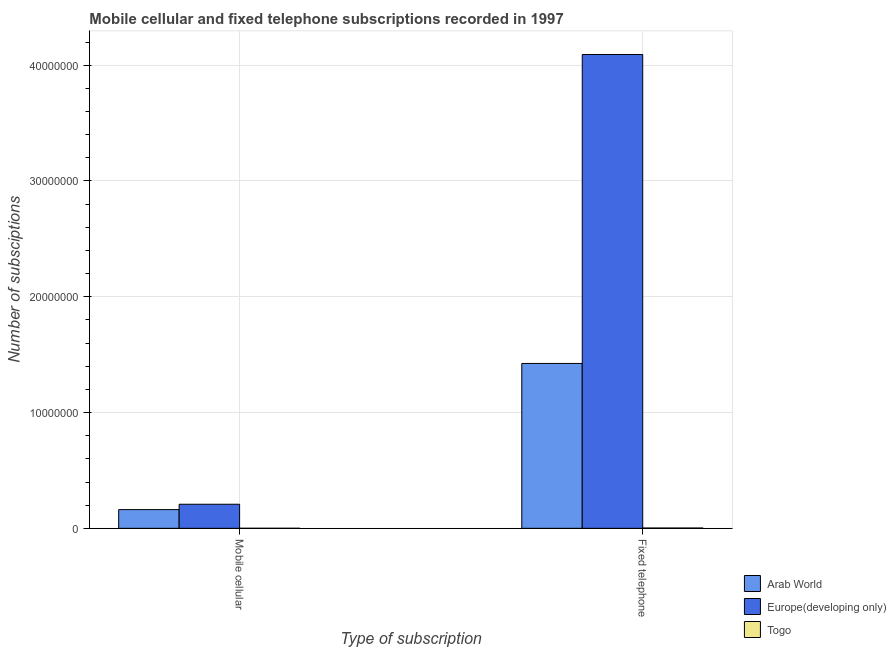How many bars are there on the 2nd tick from the right?
Provide a succinct answer. 3. What is the label of the 2nd group of bars from the left?
Offer a very short reply. Fixed telephone. What is the number of fixed telephone subscriptions in Arab World?
Make the answer very short. 1.42e+07. Across all countries, what is the maximum number of fixed telephone subscriptions?
Make the answer very short. 4.09e+07. Across all countries, what is the minimum number of mobile cellular subscriptions?
Offer a terse response. 2995. In which country was the number of mobile cellular subscriptions maximum?
Your answer should be compact. Europe(developing only). In which country was the number of fixed telephone subscriptions minimum?
Provide a short and direct response. Togo. What is the total number of mobile cellular subscriptions in the graph?
Provide a short and direct response. 3.70e+06. What is the difference between the number of mobile cellular subscriptions in Europe(developing only) and that in Togo?
Make the answer very short. 2.08e+06. What is the difference between the number of mobile cellular subscriptions in Arab World and the number of fixed telephone subscriptions in Europe(developing only)?
Keep it short and to the point. -3.93e+07. What is the average number of fixed telephone subscriptions per country?
Ensure brevity in your answer.  1.84e+07. What is the difference between the number of fixed telephone subscriptions and number of mobile cellular subscriptions in Europe(developing only)?
Provide a short and direct response. 3.88e+07. In how many countries, is the number of fixed telephone subscriptions greater than 2000000 ?
Offer a terse response. 2. What is the ratio of the number of fixed telephone subscriptions in Togo to that in Arab World?
Provide a short and direct response. 0. Is the number of fixed telephone subscriptions in Togo less than that in Europe(developing only)?
Keep it short and to the point. Yes. What does the 3rd bar from the left in Mobile cellular represents?
Offer a terse response. Togo. What does the 1st bar from the right in Mobile cellular represents?
Give a very brief answer. Togo. How many bars are there?
Offer a terse response. 6. How many countries are there in the graph?
Provide a short and direct response. 3. Are the values on the major ticks of Y-axis written in scientific E-notation?
Offer a very short reply. No. Does the graph contain any zero values?
Your answer should be very brief. No. Does the graph contain grids?
Your response must be concise. Yes. Where does the legend appear in the graph?
Keep it short and to the point. Bottom right. What is the title of the graph?
Make the answer very short. Mobile cellular and fixed telephone subscriptions recorded in 1997. What is the label or title of the X-axis?
Give a very brief answer. Type of subscription. What is the label or title of the Y-axis?
Your answer should be compact. Number of subsciptions. What is the Number of subsciptions of Arab World in Mobile cellular?
Provide a succinct answer. 1.62e+06. What is the Number of subsciptions in Europe(developing only) in Mobile cellular?
Offer a terse response. 2.08e+06. What is the Number of subsciptions in Togo in Mobile cellular?
Your answer should be compact. 2995. What is the Number of subsciptions in Arab World in Fixed telephone?
Your answer should be compact. 1.42e+07. What is the Number of subsciptions of Europe(developing only) in Fixed telephone?
Give a very brief answer. 4.09e+07. What is the Number of subsciptions of Togo in Fixed telephone?
Give a very brief answer. 2.51e+04. Across all Type of subscription, what is the maximum Number of subsciptions in Arab World?
Offer a terse response. 1.42e+07. Across all Type of subscription, what is the maximum Number of subsciptions of Europe(developing only)?
Ensure brevity in your answer.  4.09e+07. Across all Type of subscription, what is the maximum Number of subsciptions in Togo?
Give a very brief answer. 2.51e+04. Across all Type of subscription, what is the minimum Number of subsciptions in Arab World?
Offer a very short reply. 1.62e+06. Across all Type of subscription, what is the minimum Number of subsciptions of Europe(developing only)?
Offer a terse response. 2.08e+06. Across all Type of subscription, what is the minimum Number of subsciptions in Togo?
Provide a succinct answer. 2995. What is the total Number of subsciptions of Arab World in the graph?
Ensure brevity in your answer.  1.59e+07. What is the total Number of subsciptions in Europe(developing only) in the graph?
Ensure brevity in your answer.  4.30e+07. What is the total Number of subsciptions of Togo in the graph?
Give a very brief answer. 2.81e+04. What is the difference between the Number of subsciptions in Arab World in Mobile cellular and that in Fixed telephone?
Your answer should be compact. -1.26e+07. What is the difference between the Number of subsciptions in Europe(developing only) in Mobile cellular and that in Fixed telephone?
Offer a very short reply. -3.88e+07. What is the difference between the Number of subsciptions of Togo in Mobile cellular and that in Fixed telephone?
Make the answer very short. -2.21e+04. What is the difference between the Number of subsciptions of Arab World in Mobile cellular and the Number of subsciptions of Europe(developing only) in Fixed telephone?
Offer a very short reply. -3.93e+07. What is the difference between the Number of subsciptions of Arab World in Mobile cellular and the Number of subsciptions of Togo in Fixed telephone?
Offer a very short reply. 1.59e+06. What is the difference between the Number of subsciptions of Europe(developing only) in Mobile cellular and the Number of subsciptions of Togo in Fixed telephone?
Your answer should be very brief. 2.05e+06. What is the average Number of subsciptions of Arab World per Type of subscription?
Keep it short and to the point. 7.93e+06. What is the average Number of subsciptions of Europe(developing only) per Type of subscription?
Provide a succinct answer. 2.15e+07. What is the average Number of subsciptions in Togo per Type of subscription?
Offer a terse response. 1.41e+04. What is the difference between the Number of subsciptions of Arab World and Number of subsciptions of Europe(developing only) in Mobile cellular?
Provide a succinct answer. -4.63e+05. What is the difference between the Number of subsciptions in Arab World and Number of subsciptions in Togo in Mobile cellular?
Your answer should be compact. 1.61e+06. What is the difference between the Number of subsciptions in Europe(developing only) and Number of subsciptions in Togo in Mobile cellular?
Your answer should be very brief. 2.08e+06. What is the difference between the Number of subsciptions of Arab World and Number of subsciptions of Europe(developing only) in Fixed telephone?
Offer a terse response. -2.67e+07. What is the difference between the Number of subsciptions in Arab World and Number of subsciptions in Togo in Fixed telephone?
Offer a terse response. 1.42e+07. What is the difference between the Number of subsciptions of Europe(developing only) and Number of subsciptions of Togo in Fixed telephone?
Ensure brevity in your answer.  4.09e+07. What is the ratio of the Number of subsciptions in Arab World in Mobile cellular to that in Fixed telephone?
Give a very brief answer. 0.11. What is the ratio of the Number of subsciptions in Europe(developing only) in Mobile cellular to that in Fixed telephone?
Your answer should be very brief. 0.05. What is the ratio of the Number of subsciptions in Togo in Mobile cellular to that in Fixed telephone?
Your answer should be very brief. 0.12. What is the difference between the highest and the second highest Number of subsciptions in Arab World?
Provide a short and direct response. 1.26e+07. What is the difference between the highest and the second highest Number of subsciptions of Europe(developing only)?
Keep it short and to the point. 3.88e+07. What is the difference between the highest and the second highest Number of subsciptions in Togo?
Your answer should be very brief. 2.21e+04. What is the difference between the highest and the lowest Number of subsciptions in Arab World?
Your response must be concise. 1.26e+07. What is the difference between the highest and the lowest Number of subsciptions in Europe(developing only)?
Give a very brief answer. 3.88e+07. What is the difference between the highest and the lowest Number of subsciptions in Togo?
Your answer should be compact. 2.21e+04. 